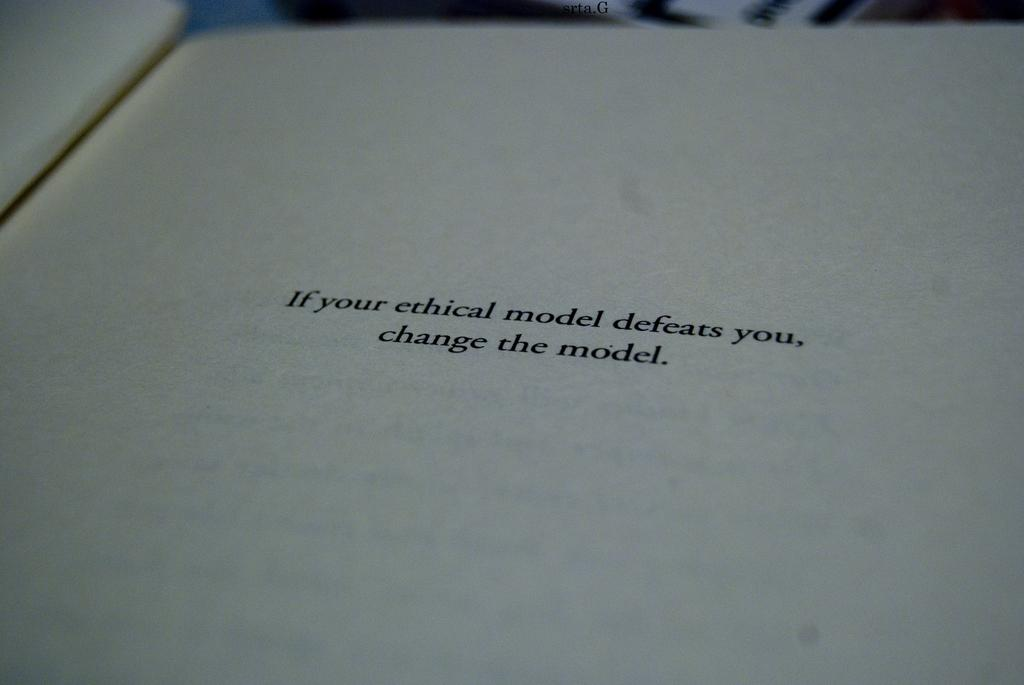<image>
Offer a succinct explanation of the picture presented. A book is open to a page that reads "If your ethical model defeats you, change the model." 